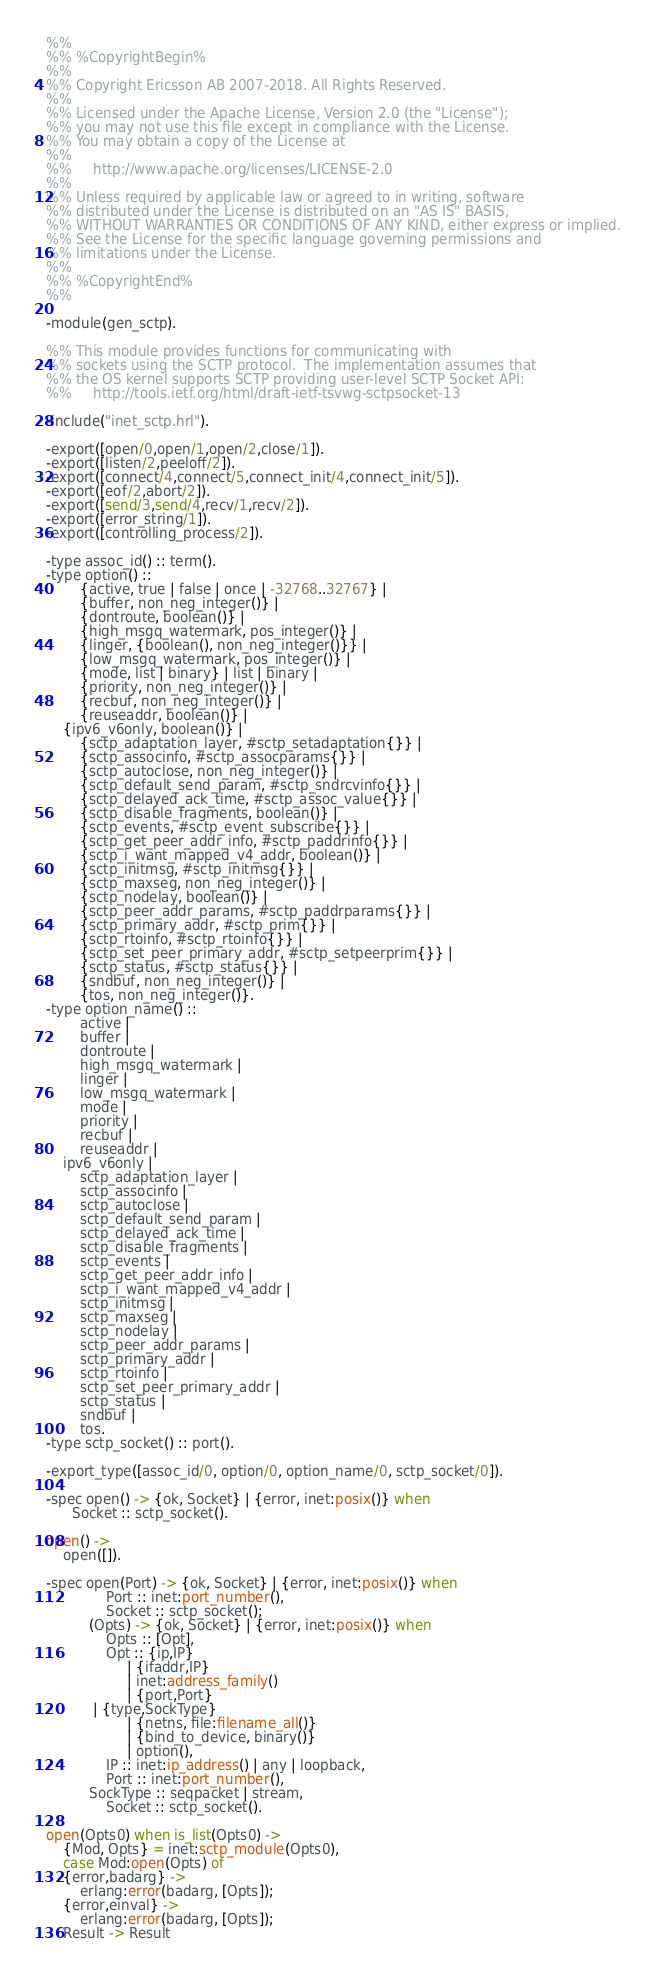<code> <loc_0><loc_0><loc_500><loc_500><_Erlang_>%%
%% %CopyrightBegin%
%%
%% Copyright Ericsson AB 2007-2018. All Rights Reserved.
%%
%% Licensed under the Apache License, Version 2.0 (the "License");
%% you may not use this file except in compliance with the License.
%% You may obtain a copy of the License at
%%
%%     http://www.apache.org/licenses/LICENSE-2.0
%%
%% Unless required by applicable law or agreed to in writing, software
%% distributed under the License is distributed on an "AS IS" BASIS,
%% WITHOUT WARRANTIES OR CONDITIONS OF ANY KIND, either express or implied.
%% See the License for the specific language governing permissions and
%% limitations under the License.
%%
%% %CopyrightEnd%
%%

-module(gen_sctp).

%% This module provides functions for communicating with
%% sockets using the SCTP protocol.  The implementation assumes that
%% the OS kernel supports SCTP providing user-level SCTP Socket API:
%%     http://tools.ietf.org/html/draft-ietf-tsvwg-sctpsocket-13

-include("inet_sctp.hrl").

-export([open/0,open/1,open/2,close/1]).
-export([listen/2,peeloff/2]).
-export([connect/4,connect/5,connect_init/4,connect_init/5]).
-export([eof/2,abort/2]).
-export([send/3,send/4,recv/1,recv/2]).
-export([error_string/1]).
-export([controlling_process/2]).

-type assoc_id() :: term().
-type option() ::
        {active, true | false | once | -32768..32767} |
        {buffer, non_neg_integer()} |
        {dontroute, boolean()} |
        {high_msgq_watermark, pos_integer()} |
        {linger, {boolean(), non_neg_integer()}} |
        {low_msgq_watermark, pos_integer()} |
        {mode, list | binary} | list | binary |
        {priority, non_neg_integer()} |
        {recbuf, non_neg_integer()} |
        {reuseaddr, boolean()} |
	{ipv6_v6only, boolean()} |
        {sctp_adaptation_layer, #sctp_setadaptation{}} |
        {sctp_associnfo, #sctp_assocparams{}} |
        {sctp_autoclose, non_neg_integer()} |
        {sctp_default_send_param, #sctp_sndrcvinfo{}} |
        {sctp_delayed_ack_time, #sctp_assoc_value{}} |
        {sctp_disable_fragments, boolean()} |
        {sctp_events, #sctp_event_subscribe{}} |
        {sctp_get_peer_addr_info, #sctp_paddrinfo{}} |
        {sctp_i_want_mapped_v4_addr, boolean()} |
        {sctp_initmsg, #sctp_initmsg{}} |
        {sctp_maxseg, non_neg_integer()} |
        {sctp_nodelay, boolean()} |
        {sctp_peer_addr_params, #sctp_paddrparams{}} |
        {sctp_primary_addr, #sctp_prim{}} |
        {sctp_rtoinfo, #sctp_rtoinfo{}} |
        {sctp_set_peer_primary_addr, #sctp_setpeerprim{}} |
        {sctp_status, #sctp_status{}} |
        {sndbuf, non_neg_integer()} |
        {tos, non_neg_integer()}.
-type option_name() ::
        active |
        buffer |
        dontroute |
        high_msgq_watermark |
        linger |
        low_msgq_watermark |
        mode |
        priority |
        recbuf |
        reuseaddr |
	ipv6_v6only |
        sctp_adaptation_layer |
        sctp_associnfo |
        sctp_autoclose |
        sctp_default_send_param |
        sctp_delayed_ack_time |
        sctp_disable_fragments |
        sctp_events |
        sctp_get_peer_addr_info |
        sctp_i_want_mapped_v4_addr |
        sctp_initmsg |
        sctp_maxseg |
        sctp_nodelay |
        sctp_peer_addr_params |
        sctp_primary_addr |
        sctp_rtoinfo |
        sctp_set_peer_primary_addr |
        sctp_status |
        sndbuf |
        tos.
-type sctp_socket() :: port().

-export_type([assoc_id/0, option/0, option_name/0, sctp_socket/0]).

-spec open() -> {ok, Socket} | {error, inet:posix()} when
      Socket :: sctp_socket().

open() ->
    open([]).

-spec open(Port) -> {ok, Socket} | {error, inet:posix()} when
              Port :: inet:port_number(),
              Socket :: sctp_socket();
          (Opts) -> {ok, Socket} | {error, inet:posix()} when
              Opts :: [Opt],
              Opt :: {ip,IP}
                   | {ifaddr,IP}
                   | inet:address_family()
                   | {port,Port}
		   | {type,SockType}
                   | {netns, file:filename_all()}
                   | {bind_to_device, binary()}
                   | option(),
              IP :: inet:ip_address() | any | loopback,
              Port :: inet:port_number(),
	      SockType :: seqpacket | stream,
              Socket :: sctp_socket().

open(Opts0) when is_list(Opts0) ->
    {Mod, Opts} = inet:sctp_module(Opts0),
    case Mod:open(Opts) of
	{error,badarg} ->
	    erlang:error(badarg, [Opts]);
	{error,einval} ->
	    erlang:error(badarg, [Opts]);
	Result -> Result</code> 